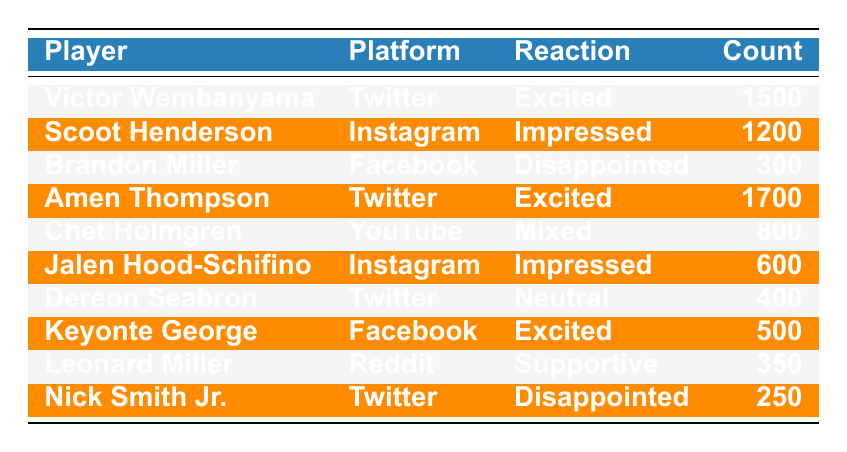What is the highest reaction count among players? By reviewing the 'Count' column in the table, the highest number is 1700, which corresponds to Amen Thompson's reaction of "Excited" on Twitter.
Answer: 1700 Which player received a "Disappointed" reaction on Twitter? The table shows that Nick Smith Jr. has a "Disappointed" reaction on Twitter with a count of 250.
Answer: Nick Smith Jr What is the total count of excited reactions from players? The excited reactions are from Victor Wembanyama (1500), Amen Thompson (1700), and Keyonte George (500). Adding these gives 1500 + 1700 + 500 = 3700.
Answer: 3700 Are there any players who received an "Impressed" reaction? Yes, both Scoot Henderson and Jalen Hood-Schifino received "Impressed" reactions.
Answer: Yes Which social media platform had the least reaction count and what was the reaction? By looking at the 'Count' column, the lowest number is 250 for Nick Smith Jr. on Twitter, who had a "Disappointed" reaction.
Answer: Twitter, Disappointed What is the average reaction count for players using Instagram? The only players on Instagram are Scoot Henderson with 1200 and Jalen Hood-Schifino with 600. The average is (1200 + 600) / 2 = 900.
Answer: 900 Was there a "Mixed" reaction reported? Yes, Chet Holmgren received a "Mixed" reaction on YouTube.
Answer: Yes How many reactions were neutral among the players? Dereon Seabron is the only player listed with a "Neutral" reaction, which has a count of 400.
Answer: 400 What is the difference between the highest and lowest counts in the table? The highest count is 1700 (Amen Thompson) and the lowest is 250 (Nick Smith Jr.). The difference is 1700 - 250 = 1450.
Answer: 1450 